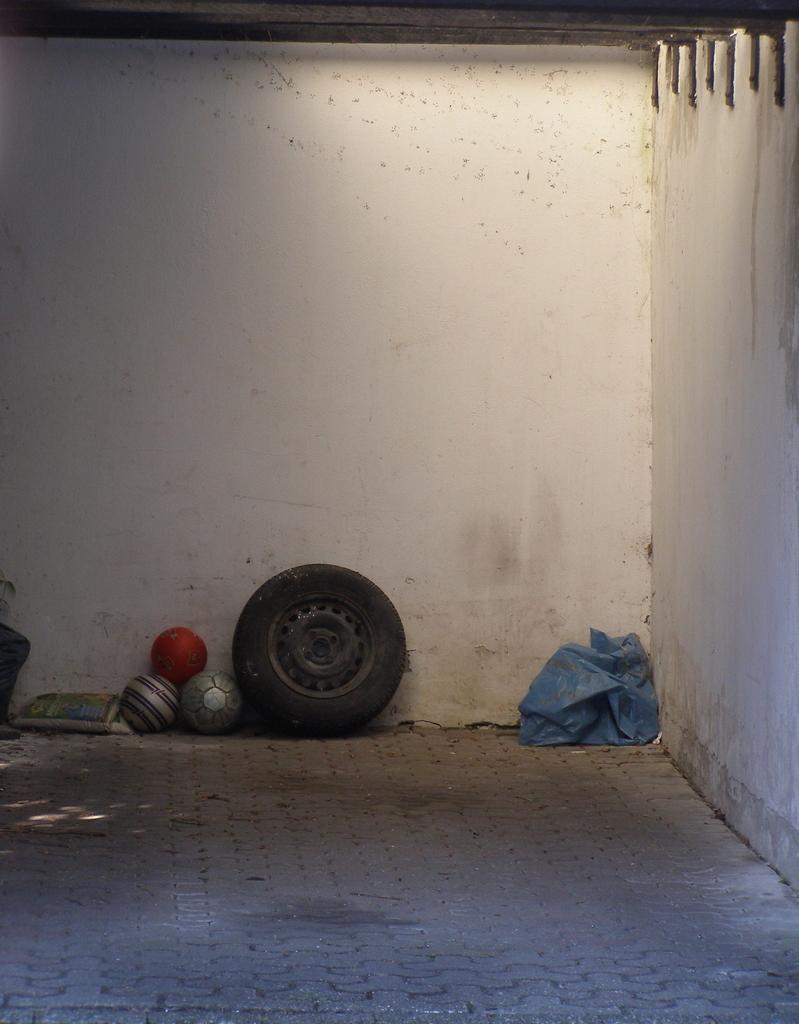Please provide a concise description of this image. In this image I can see few balls, tier, blue color plastic cover and few objects on the floor. I can see the wall. 